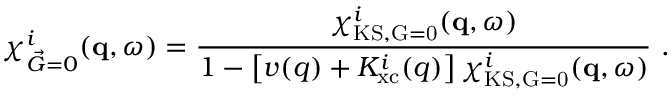Convert formula to latex. <formula><loc_0><loc_0><loc_500><loc_500>\chi _ { \vec { G } = 0 } ^ { i } ( q , \omega ) = \frac { \chi _ { K S , \vec { G } = 0 } ^ { i } ( q , \omega ) } { 1 - \left [ v ( q ) + K _ { x c } ^ { i } ( q ) \right ] \chi _ { K S , \vec { G } = 0 } ^ { i } ( q , \omega ) } \ .</formula> 